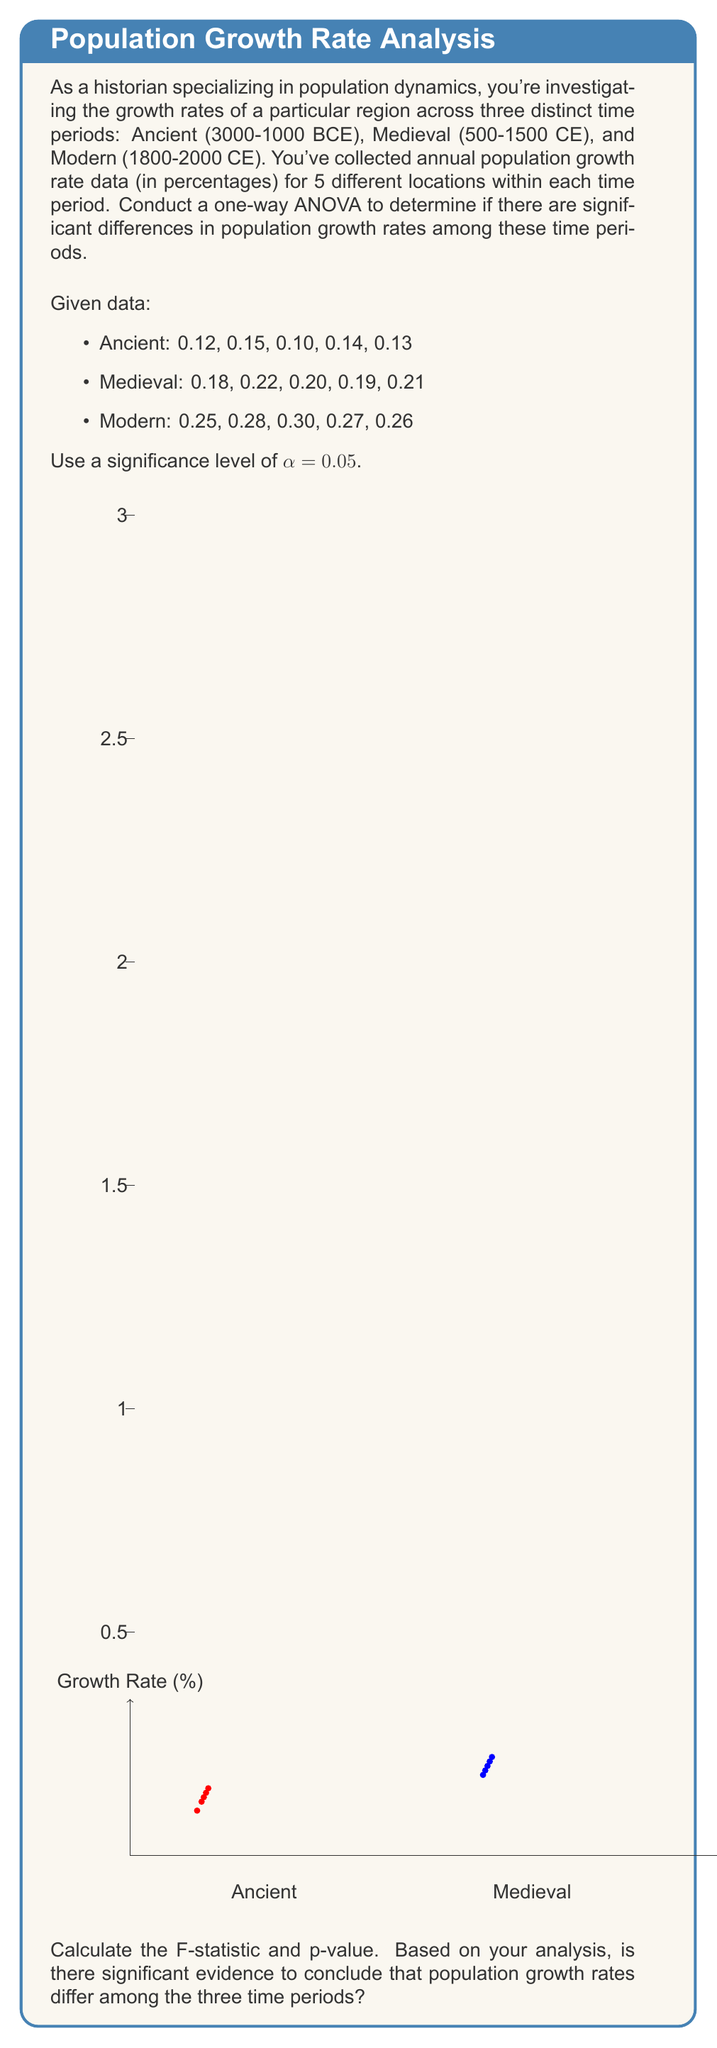Can you answer this question? Let's approach this step-by-step:

1) First, calculate the means for each group:
   Ancient: $\bar{X}_1 = \frac{0.12 + 0.15 + 0.10 + 0.14 + 0.13}{5} = 0.128$
   Medieval: $\bar{X}_2 = \frac{0.18 + 0.22 + 0.20 + 0.19 + 0.21}{5} = 0.200$
   Modern: $\bar{X}_3 = \frac{0.25 + 0.28 + 0.30 + 0.27 + 0.26}{5} = 0.272$

2) Calculate the grand mean:
   $\bar{X} = \frac{0.128 + 0.200 + 0.272}{3} = 0.200$

3) Calculate SSB (Sum of Squares Between groups):
   $$SSB = 5[(0.128 - 0.200)^2 + (0.200 - 0.200)^2 + (0.272 - 0.200)^2] = 0.0516$$

4) Calculate SSW (Sum of Squares Within groups):
   $$SSW = \sum_{i=1}^{3}\sum_{j=1}^{5}(X_{ij} - \bar{X}_i)^2 = 0.00142$$

5) Calculate degrees of freedom:
   dfB (between) = 3 - 1 = 2
   dfW (within) = 15 - 3 = 12
   dfT (total) = 15 - 1 = 14

6) Calculate MSB and MSW:
   $$MSB = \frac{SSB}{dfB} = \frac{0.0516}{2} = 0.0258$$
   $$MSW = \frac{SSW}{dfW} = \frac{0.00142}{12} = 0.0001183$$

7) Calculate F-statistic:
   $$F = \frac{MSB}{MSW} = \frac{0.0258}{0.0001183} = 218.09$$

8) Find the critical F-value:
   For α = 0.05, dfB = 2, dfW = 12, F-critical ≈ 3.89

9) Calculate p-value:
   The p-value for F(2,12) = 218.09 is extremely small (p < 0.0001)

10) Decision:
    Since F (218.09) > F-critical (3.89) and p-value (< 0.0001) < α (0.05), we reject the null hypothesis.
Answer: F(2,12) = 218.09, p < 0.0001. There is significant evidence to conclude that population growth rates differ among the three time periods. 